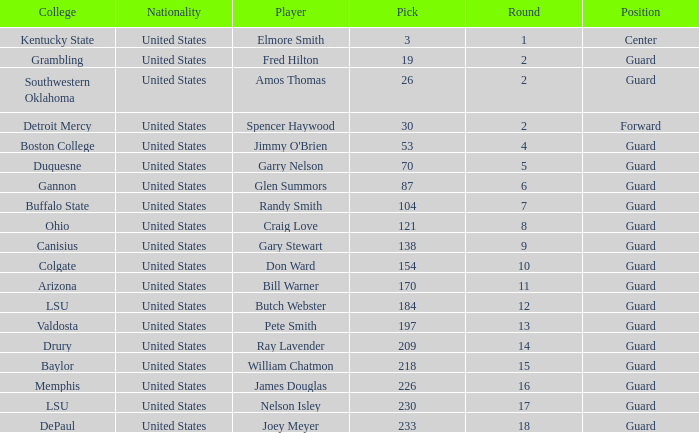WHAT IS THE TOTAL PICK FOR BOSTON COLLEGE? 1.0. 